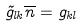<formula> <loc_0><loc_0><loc_500><loc_500>\tilde { g } _ { l k } \overline { n } = g _ { k l }</formula> 